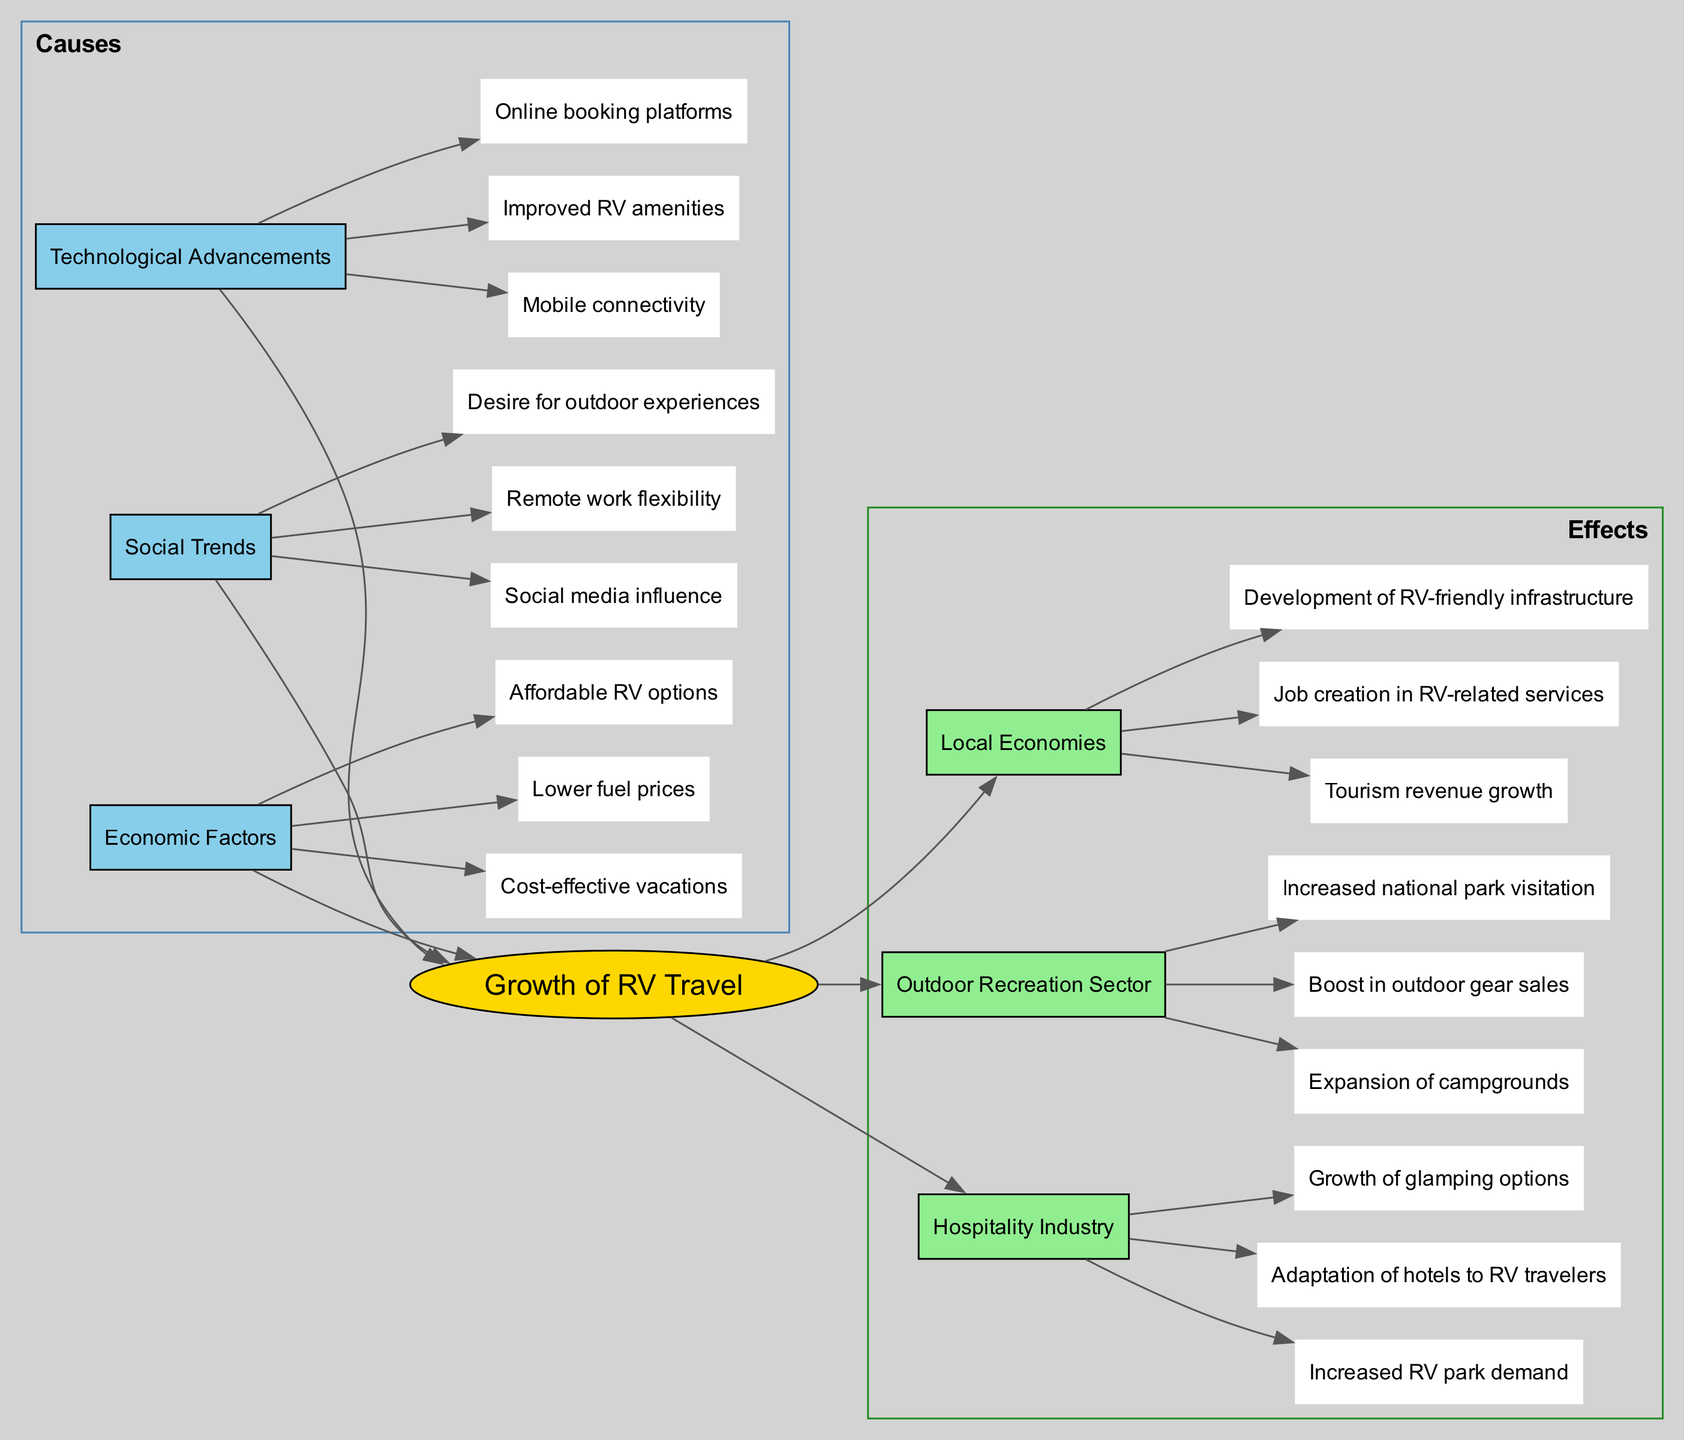What is the central topic of the diagram? The central topic is explicitly labeled in the diagram as "Growth of RV Travel," which serves as the main point around which all other nodes are organized.
Answer: Growth of RV Travel How many main causes are identified in the diagram? The diagram lists three main causes: Economic Factors, Social Trends, and Technological Advancements. Counting these gives a total of three.
Answer: 3 What sub-factor is mentioned under Social Trends? One of the sub-factors listed under Social Trends is "Desire for outdoor experiences." This can be found by reviewing the sub-nodes connected to the Social Trends main node.
Answer: Desire for outdoor experiences Which effect relates to job creation? The effect related to job creation is "Job creation in RV-related services," found under the Local Economies section of the effects.
Answer: Job creation in RV-related services Explain how improved RV amenities contribute to the hospitality industry. Improved RV amenities are part of the Technological Advancements causes, which positively affect the hospitality industry by leading to "Adaptation of hotels to RV travelers." This illustrates a connection between technology and hospitality responses to RV travel growth.
Answer: Adaptation of hotels to RV travelers What is the relationship between lower fuel prices and the growth of RV travel? Lower fuel prices are classified as an Economic Factor, and they directly contribute to the Growth of RV Travel by making it more affordable for travelers to operate their RVs, which encourages increased RV travel overall.
Answer: Contributes positively How does the increased national park visitation relate to the outdoor recreation sector? Increased national park visitation is one of the effects listed under the Outdoor Recreation Sector. It indicates that the rise in RV travel leads to more people visiting national parks, illustrating a connection between increased RV usage and outdoor recreational activities.
Answer: Increased national park visitation Which sub-node indicates a new type of accommodation option in the hospitality industry? "Growth of glamping options" is a sub-node under the Hospitality Industry effects that indicates the emergence of a new trend in accommodation catering to RV travelers looking for unique lodging experiences.
Answer: Growth of glamping options How many total nodes are there for causes in the diagram? The diagram lists three main cause nodes, and each main node has multiple sub-nodes. Counting each sub-node gives a total of eight cause-related nodes (3 main + 5 sub). Thus, the total amount is eight nodes for causes.
Answer: 8 